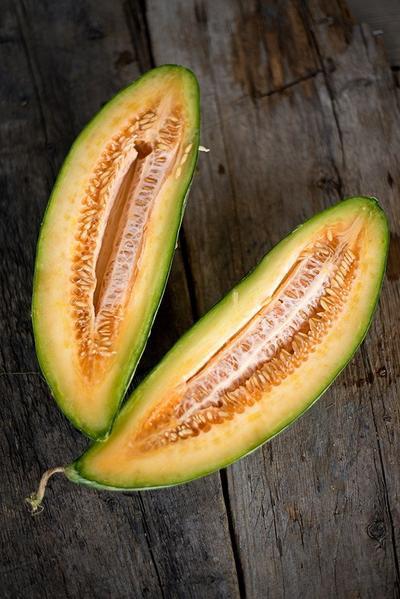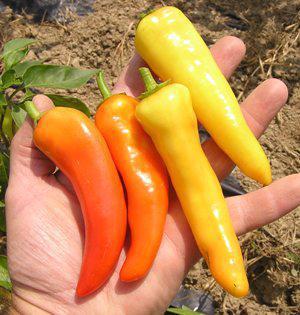The first image is the image on the left, the second image is the image on the right. For the images shown, is this caption "The right image shows a neat row of picked peppers that includes red, orange, and yellow color varieties." true? Answer yes or no. No. The first image is the image on the left, the second image is the image on the right. For the images shown, is this caption "Both images in the pair show hot peppers that are yellow, orange, red, and green." true? Answer yes or no. No. 